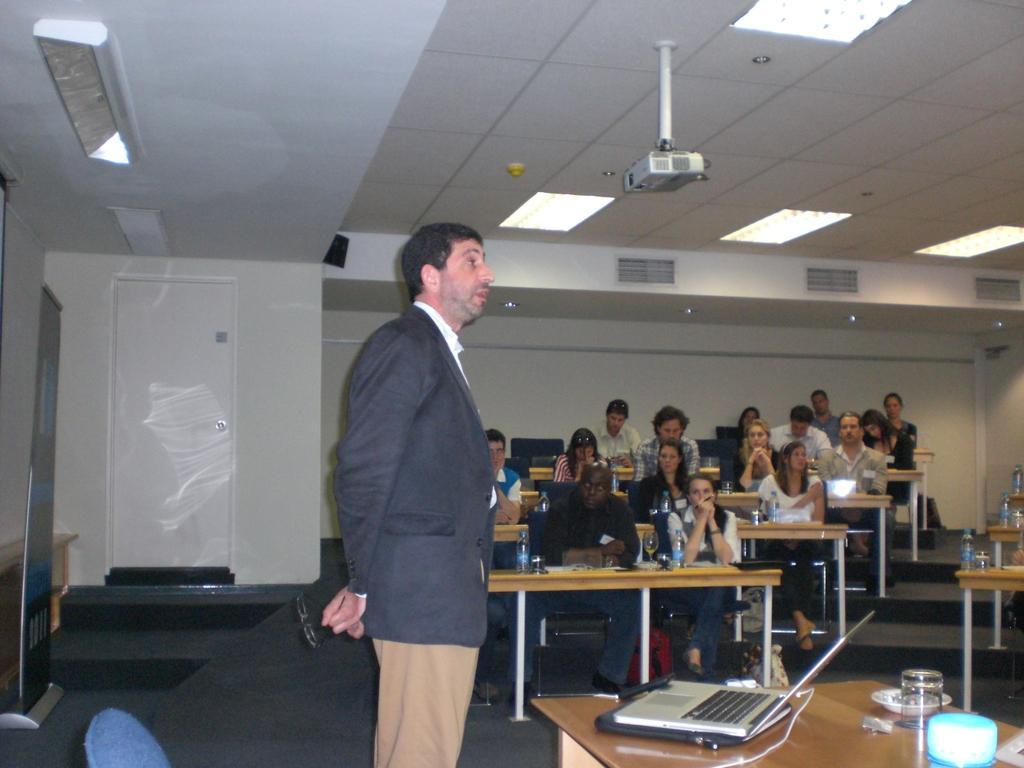In one or two sentences, can you explain what this image depicts? In this picture i could see some persons sitting on the chairs and a person standing and giving a seminar on the table there is a laptop glass in the background i could see a door and a wall. 